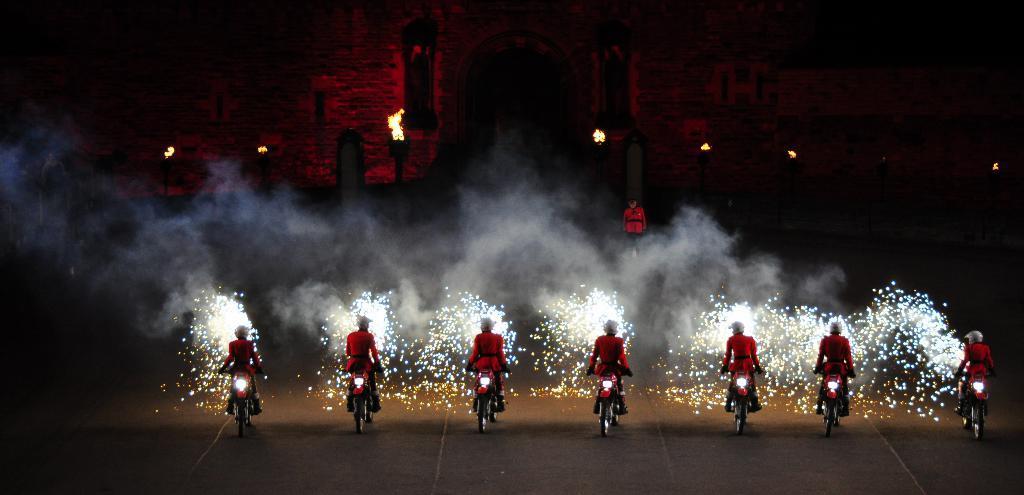Please provide a concise description of this image. In this picture we can see a group of people riding the bicycles on the road. In front of the people, those are looking like firecrackers and a person is standing. Behind the person, those are looking like fire torches and a building. 